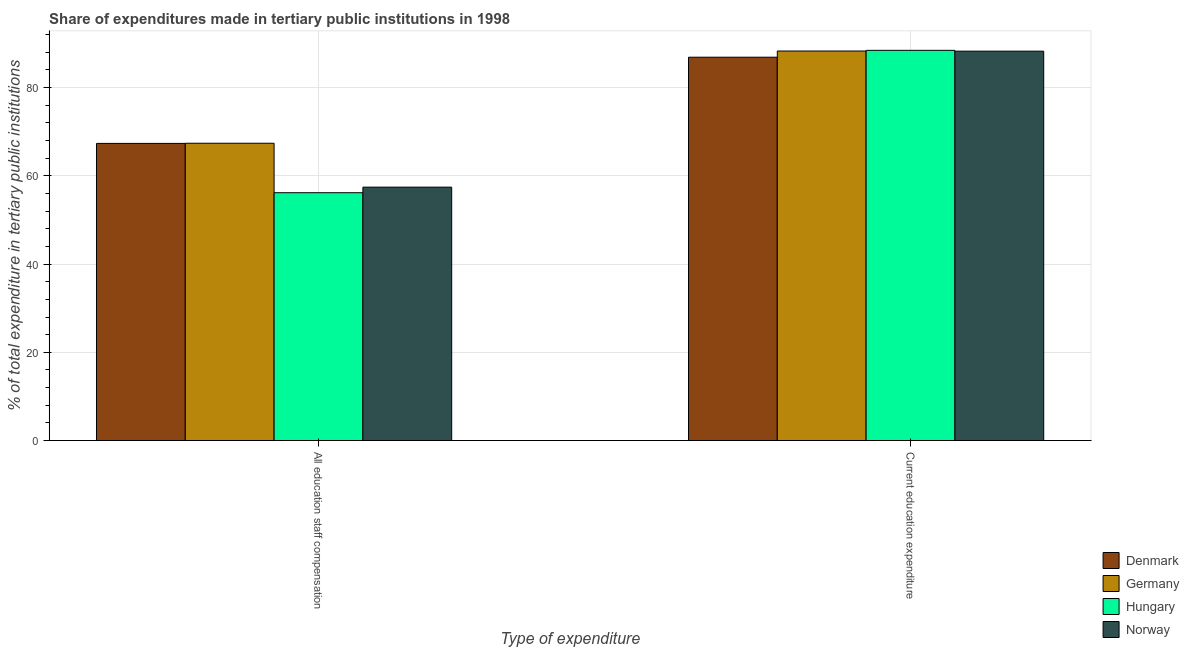How many different coloured bars are there?
Provide a short and direct response. 4. How many groups of bars are there?
Your answer should be very brief. 2. Are the number of bars per tick equal to the number of legend labels?
Keep it short and to the point. Yes. Are the number of bars on each tick of the X-axis equal?
Your answer should be very brief. Yes. What is the label of the 1st group of bars from the left?
Your response must be concise. All education staff compensation. What is the expenditure in staff compensation in Germany?
Make the answer very short. 67.39. Across all countries, what is the maximum expenditure in staff compensation?
Make the answer very short. 67.39. Across all countries, what is the minimum expenditure in staff compensation?
Your response must be concise. 56.18. In which country was the expenditure in staff compensation maximum?
Offer a terse response. Germany. What is the total expenditure in staff compensation in the graph?
Your response must be concise. 248.35. What is the difference between the expenditure in education in Denmark and that in Norway?
Your answer should be very brief. -1.37. What is the difference between the expenditure in staff compensation in Norway and the expenditure in education in Hungary?
Provide a succinct answer. -31.01. What is the average expenditure in staff compensation per country?
Ensure brevity in your answer.  62.09. What is the difference between the expenditure in education and expenditure in staff compensation in Hungary?
Ensure brevity in your answer.  32.27. What is the ratio of the expenditure in staff compensation in Germany to that in Hungary?
Offer a terse response. 1.2. What does the 4th bar from the left in Current education expenditure represents?
Your answer should be very brief. Norway. What does the 4th bar from the right in Current education expenditure represents?
Your answer should be compact. Denmark. How many bars are there?
Provide a short and direct response. 8. Are all the bars in the graph horizontal?
Your answer should be compact. No. How many countries are there in the graph?
Offer a terse response. 4. Are the values on the major ticks of Y-axis written in scientific E-notation?
Make the answer very short. No. Does the graph contain any zero values?
Make the answer very short. No. How many legend labels are there?
Ensure brevity in your answer.  4. How are the legend labels stacked?
Offer a terse response. Vertical. What is the title of the graph?
Your answer should be compact. Share of expenditures made in tertiary public institutions in 1998. Does "Cameroon" appear as one of the legend labels in the graph?
Provide a short and direct response. No. What is the label or title of the X-axis?
Ensure brevity in your answer.  Type of expenditure. What is the label or title of the Y-axis?
Give a very brief answer. % of total expenditure in tertiary public institutions. What is the % of total expenditure in tertiary public institutions in Denmark in All education staff compensation?
Keep it short and to the point. 67.35. What is the % of total expenditure in tertiary public institutions in Germany in All education staff compensation?
Your answer should be compact. 67.39. What is the % of total expenditure in tertiary public institutions of Hungary in All education staff compensation?
Your response must be concise. 56.18. What is the % of total expenditure in tertiary public institutions of Norway in All education staff compensation?
Provide a succinct answer. 57.44. What is the % of total expenditure in tertiary public institutions in Denmark in Current education expenditure?
Provide a short and direct response. 86.89. What is the % of total expenditure in tertiary public institutions of Germany in Current education expenditure?
Your answer should be compact. 88.29. What is the % of total expenditure in tertiary public institutions in Hungary in Current education expenditure?
Provide a short and direct response. 88.44. What is the % of total expenditure in tertiary public institutions in Norway in Current education expenditure?
Make the answer very short. 88.26. Across all Type of expenditure, what is the maximum % of total expenditure in tertiary public institutions in Denmark?
Provide a short and direct response. 86.89. Across all Type of expenditure, what is the maximum % of total expenditure in tertiary public institutions of Germany?
Provide a succinct answer. 88.29. Across all Type of expenditure, what is the maximum % of total expenditure in tertiary public institutions of Hungary?
Provide a short and direct response. 88.44. Across all Type of expenditure, what is the maximum % of total expenditure in tertiary public institutions of Norway?
Make the answer very short. 88.26. Across all Type of expenditure, what is the minimum % of total expenditure in tertiary public institutions in Denmark?
Your answer should be compact. 67.35. Across all Type of expenditure, what is the minimum % of total expenditure in tertiary public institutions of Germany?
Ensure brevity in your answer.  67.39. Across all Type of expenditure, what is the minimum % of total expenditure in tertiary public institutions of Hungary?
Your response must be concise. 56.18. Across all Type of expenditure, what is the minimum % of total expenditure in tertiary public institutions in Norway?
Provide a short and direct response. 57.44. What is the total % of total expenditure in tertiary public institutions in Denmark in the graph?
Keep it short and to the point. 154.24. What is the total % of total expenditure in tertiary public institutions in Germany in the graph?
Ensure brevity in your answer.  155.68. What is the total % of total expenditure in tertiary public institutions of Hungary in the graph?
Offer a terse response. 144.62. What is the total % of total expenditure in tertiary public institutions of Norway in the graph?
Provide a short and direct response. 145.69. What is the difference between the % of total expenditure in tertiary public institutions in Denmark in All education staff compensation and that in Current education expenditure?
Make the answer very short. -19.54. What is the difference between the % of total expenditure in tertiary public institutions of Germany in All education staff compensation and that in Current education expenditure?
Your answer should be very brief. -20.9. What is the difference between the % of total expenditure in tertiary public institutions of Hungary in All education staff compensation and that in Current education expenditure?
Ensure brevity in your answer.  -32.27. What is the difference between the % of total expenditure in tertiary public institutions of Norway in All education staff compensation and that in Current education expenditure?
Offer a terse response. -30.82. What is the difference between the % of total expenditure in tertiary public institutions in Denmark in All education staff compensation and the % of total expenditure in tertiary public institutions in Germany in Current education expenditure?
Ensure brevity in your answer.  -20.94. What is the difference between the % of total expenditure in tertiary public institutions in Denmark in All education staff compensation and the % of total expenditure in tertiary public institutions in Hungary in Current education expenditure?
Offer a very short reply. -21.09. What is the difference between the % of total expenditure in tertiary public institutions in Denmark in All education staff compensation and the % of total expenditure in tertiary public institutions in Norway in Current education expenditure?
Provide a succinct answer. -20.91. What is the difference between the % of total expenditure in tertiary public institutions of Germany in All education staff compensation and the % of total expenditure in tertiary public institutions of Hungary in Current education expenditure?
Offer a very short reply. -21.06. What is the difference between the % of total expenditure in tertiary public institutions of Germany in All education staff compensation and the % of total expenditure in tertiary public institutions of Norway in Current education expenditure?
Keep it short and to the point. -20.87. What is the difference between the % of total expenditure in tertiary public institutions in Hungary in All education staff compensation and the % of total expenditure in tertiary public institutions in Norway in Current education expenditure?
Your answer should be very brief. -32.08. What is the average % of total expenditure in tertiary public institutions in Denmark per Type of expenditure?
Your answer should be compact. 77.12. What is the average % of total expenditure in tertiary public institutions in Germany per Type of expenditure?
Make the answer very short. 77.84. What is the average % of total expenditure in tertiary public institutions in Hungary per Type of expenditure?
Offer a very short reply. 72.31. What is the average % of total expenditure in tertiary public institutions of Norway per Type of expenditure?
Provide a succinct answer. 72.85. What is the difference between the % of total expenditure in tertiary public institutions of Denmark and % of total expenditure in tertiary public institutions of Germany in All education staff compensation?
Make the answer very short. -0.04. What is the difference between the % of total expenditure in tertiary public institutions of Denmark and % of total expenditure in tertiary public institutions of Hungary in All education staff compensation?
Keep it short and to the point. 11.17. What is the difference between the % of total expenditure in tertiary public institutions in Denmark and % of total expenditure in tertiary public institutions in Norway in All education staff compensation?
Provide a short and direct response. 9.91. What is the difference between the % of total expenditure in tertiary public institutions in Germany and % of total expenditure in tertiary public institutions in Hungary in All education staff compensation?
Your answer should be very brief. 11.21. What is the difference between the % of total expenditure in tertiary public institutions in Germany and % of total expenditure in tertiary public institutions in Norway in All education staff compensation?
Your response must be concise. 9.95. What is the difference between the % of total expenditure in tertiary public institutions of Hungary and % of total expenditure in tertiary public institutions of Norway in All education staff compensation?
Provide a short and direct response. -1.26. What is the difference between the % of total expenditure in tertiary public institutions of Denmark and % of total expenditure in tertiary public institutions of Germany in Current education expenditure?
Provide a succinct answer. -1.41. What is the difference between the % of total expenditure in tertiary public institutions in Denmark and % of total expenditure in tertiary public institutions in Hungary in Current education expenditure?
Give a very brief answer. -1.56. What is the difference between the % of total expenditure in tertiary public institutions of Denmark and % of total expenditure in tertiary public institutions of Norway in Current education expenditure?
Your answer should be very brief. -1.37. What is the difference between the % of total expenditure in tertiary public institutions in Germany and % of total expenditure in tertiary public institutions in Hungary in Current education expenditure?
Your answer should be very brief. -0.15. What is the difference between the % of total expenditure in tertiary public institutions of Germany and % of total expenditure in tertiary public institutions of Norway in Current education expenditure?
Keep it short and to the point. 0.04. What is the difference between the % of total expenditure in tertiary public institutions in Hungary and % of total expenditure in tertiary public institutions in Norway in Current education expenditure?
Provide a short and direct response. 0.19. What is the ratio of the % of total expenditure in tertiary public institutions of Denmark in All education staff compensation to that in Current education expenditure?
Make the answer very short. 0.78. What is the ratio of the % of total expenditure in tertiary public institutions in Germany in All education staff compensation to that in Current education expenditure?
Offer a terse response. 0.76. What is the ratio of the % of total expenditure in tertiary public institutions of Hungary in All education staff compensation to that in Current education expenditure?
Keep it short and to the point. 0.64. What is the ratio of the % of total expenditure in tertiary public institutions of Norway in All education staff compensation to that in Current education expenditure?
Give a very brief answer. 0.65. What is the difference between the highest and the second highest % of total expenditure in tertiary public institutions in Denmark?
Your response must be concise. 19.54. What is the difference between the highest and the second highest % of total expenditure in tertiary public institutions in Germany?
Ensure brevity in your answer.  20.9. What is the difference between the highest and the second highest % of total expenditure in tertiary public institutions in Hungary?
Your answer should be compact. 32.27. What is the difference between the highest and the second highest % of total expenditure in tertiary public institutions in Norway?
Make the answer very short. 30.82. What is the difference between the highest and the lowest % of total expenditure in tertiary public institutions of Denmark?
Provide a succinct answer. 19.54. What is the difference between the highest and the lowest % of total expenditure in tertiary public institutions in Germany?
Keep it short and to the point. 20.9. What is the difference between the highest and the lowest % of total expenditure in tertiary public institutions of Hungary?
Ensure brevity in your answer.  32.27. What is the difference between the highest and the lowest % of total expenditure in tertiary public institutions in Norway?
Offer a terse response. 30.82. 